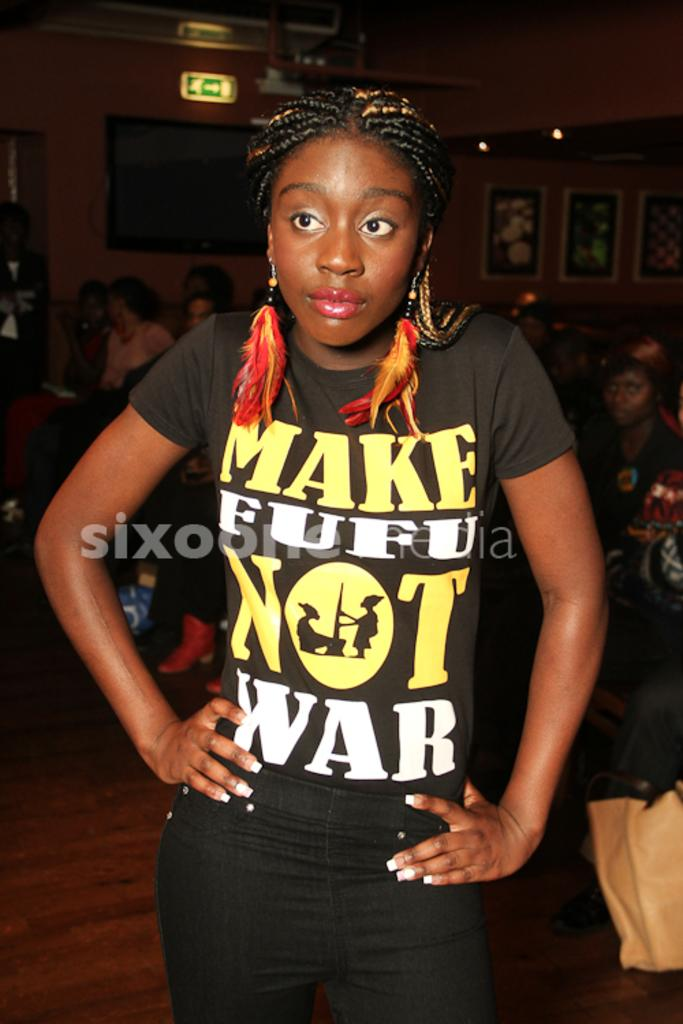Provide a one-sentence caption for the provided image. Girl wearing a black shirt with Make Fufu Not War in yellow and white letters. 